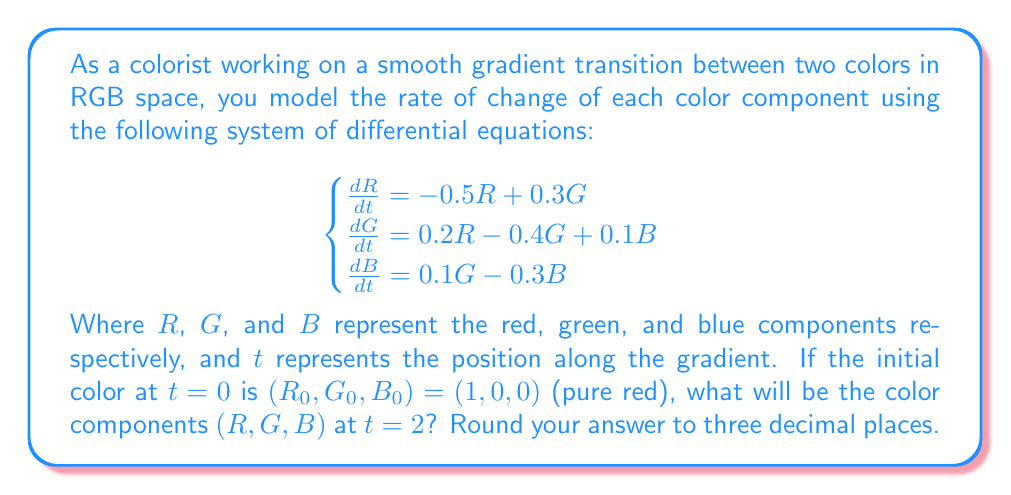What is the answer to this math problem? To solve this system of linear differential equations, we can use matrix methods:

1) First, rewrite the system in matrix form:

   $$\frac{d}{dt}\begin{bmatrix}R \\ G \\ B\end{bmatrix} = \begin{bmatrix}-0.5 & 0.3 & 0 \\ 0.2 & -0.4 & 0.1 \\ 0 & 0.1 & -0.3\end{bmatrix}\begin{bmatrix}R \\ G \\ B\end{bmatrix}$$

2) Let's call the matrix $A$. The solution to this system is of the form:

   $$\begin{bmatrix}R(t) \\ G(t) \\ B(t)\end{bmatrix} = e^{At}\begin{bmatrix}R_0 \\ G_0 \\ B_0\end{bmatrix}$$

3) To compute $e^{At}$, we need to find the eigenvalues and eigenvectors of $A$. Using a computer algebra system, we find:

   Eigenvalues: $\lambda_1 \approx -0.7101$, $\lambda_2 \approx -0.2949$, $\lambda_3 \approx -0.1950$

   Eigenvectors:
   $$v_1 \approx \begin{bmatrix}-0.8660 \\ 0.4852 \\ -0.1185\end{bmatrix}, v_2 \approx \begin{bmatrix}-0.3476 \\ -0.6645 \\ 0.6618\end{bmatrix}, v_3 \approx \begin{bmatrix}-0.0838 \\ -0.5350 \\ -0.8407\end{bmatrix}$$

4) The solution can be written as:

   $$\begin{bmatrix}R(t) \\ G(t) \\ B(t)\end{bmatrix} = c_1e^{\lambda_1t}v_1 + c_2e^{\lambda_2t}v_2 + c_3e^{\lambda_3t}v_3$$

5) Using the initial condition $(R_0, G_0, B_0) = (1, 0, 0)$, we can solve for $c_1$, $c_2$, and $c_3$:

   $$c_1 \approx -1.0972, c_2 \approx -0.2879, c_3 \approx -0.0382$$

6) Now we can compute the color components at $t=2$:

   $$\begin{bmatrix}R(2) \\ G(2) \\ B(2)\end{bmatrix} \approx -1.0972e^{-0.7101 \cdot 2}\begin{bmatrix}-0.8660 \\ 0.4852 \\ -0.1185\end{bmatrix} - 0.2879e^{-0.2949 \cdot 2}\begin{bmatrix}-0.3476 \\ -0.6645 \\ 0.6618\end{bmatrix} - 0.0382e^{-0.1950 \cdot 2}\begin{bmatrix}-0.0838 \\ -0.5350 \\ -0.8407\end{bmatrix}$$

7) Evaluating this expression:

   $$\begin{bmatrix}R(2) \\ G(2) \\ B(2)\end{bmatrix} \approx \begin{bmatrix}0.2554 \\ 0.1440 \\ 0.0569\end{bmatrix}$$

8) Rounding to three decimal places:

   $$\begin{bmatrix}R(2) \\ G(2) \\ B(2)\end{bmatrix} \approx \begin{bmatrix}0.255 \\ 0.144 \\ 0.057\end{bmatrix}$$
Answer: $(0.255, 0.144, 0.057)$ 